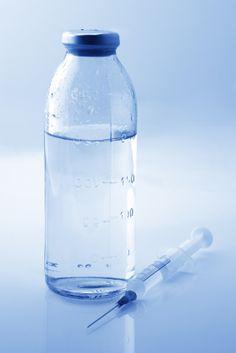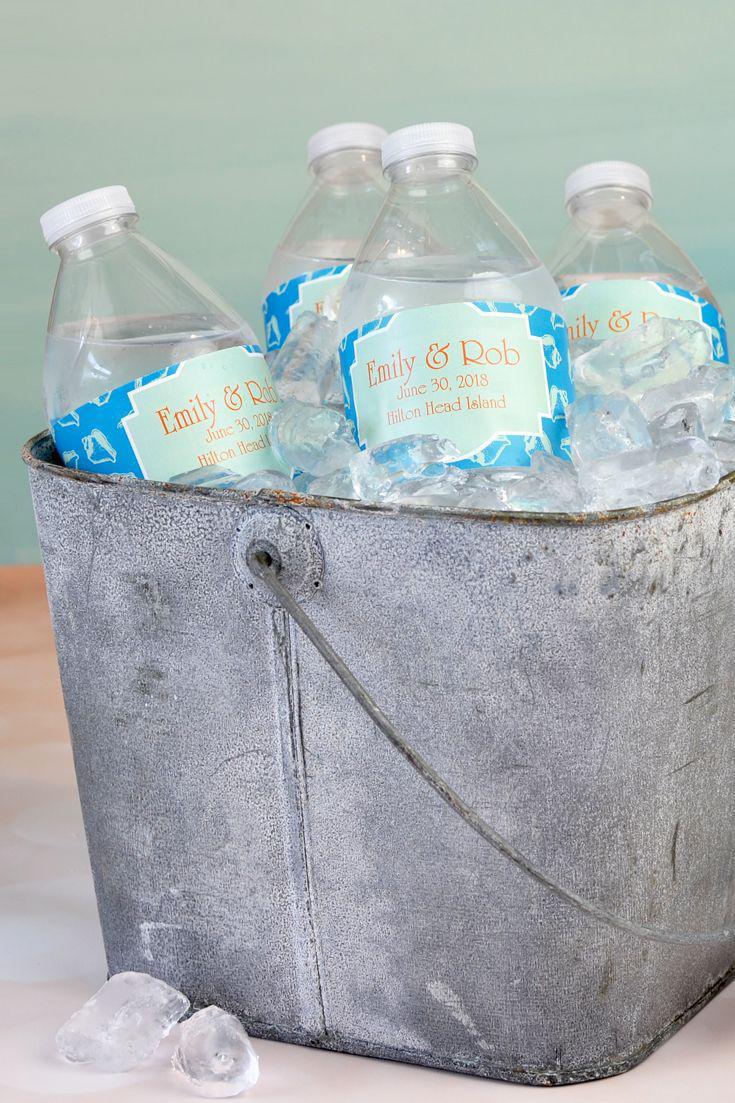The first image is the image on the left, the second image is the image on the right. Considering the images on both sides, is "An image shows multiple water bottles surrounded by ice cubes." valid? Answer yes or no. Yes. The first image is the image on the left, the second image is the image on the right. For the images displayed, is the sentence "At least three of the bottles in one of the images has a blue cap." factually correct? Answer yes or no. No. 